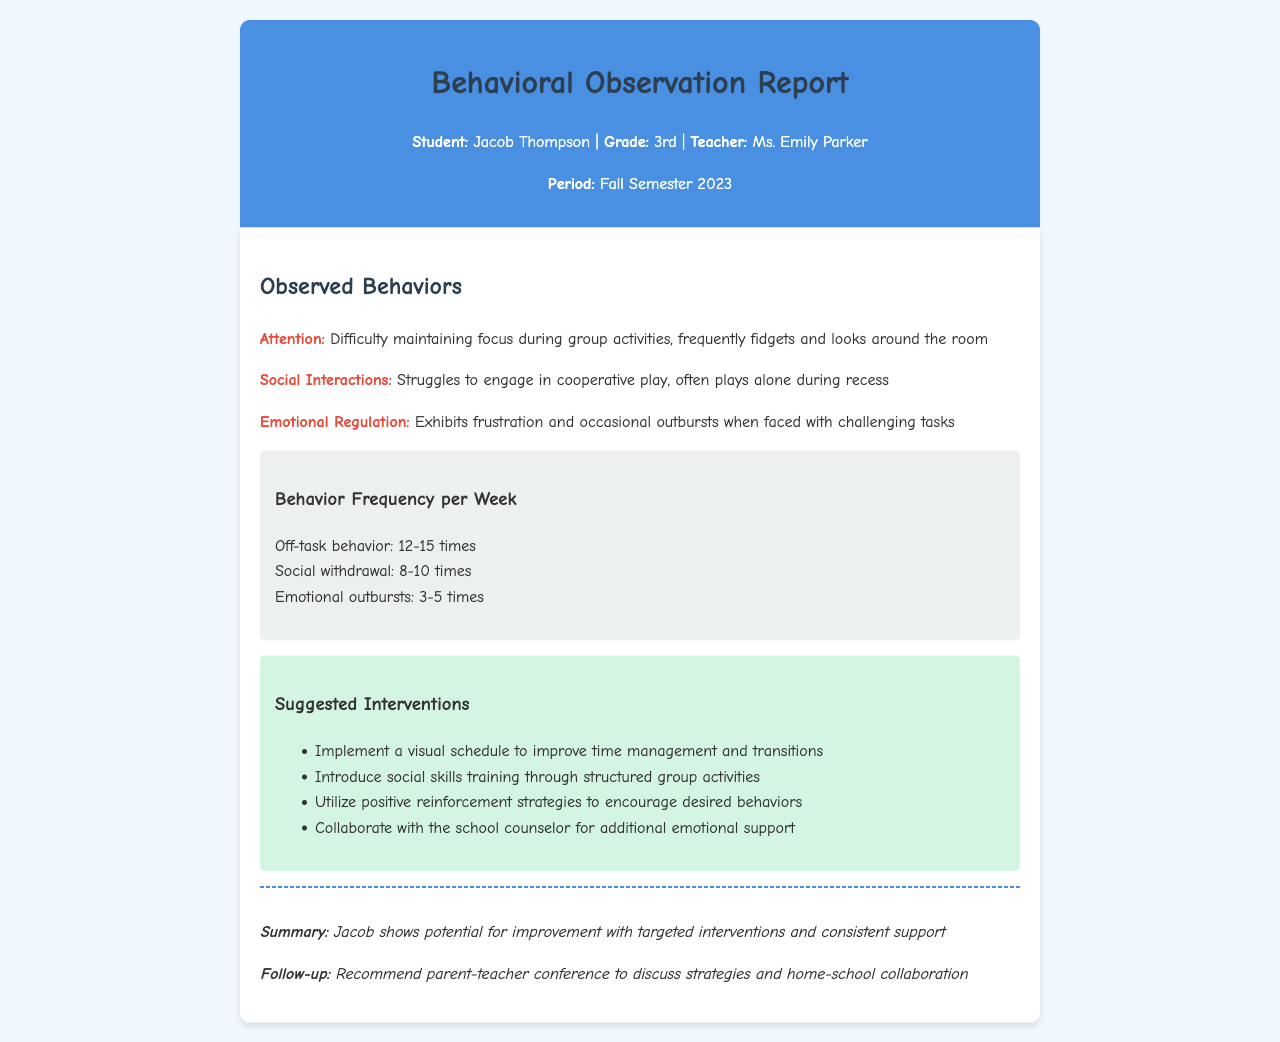What is the student's name? The student's name is clearly stated at the beginning of the document under the student details.
Answer: Jacob Thompson What grade is Jacob in? The grade is mentioned in the student details section of the document.
Answer: 3rd Which teacher is associated with this report? The teacher's name is listed in the student details section.
Answer: Ms. Emily Parker What was the observed frequency of emotional outbursts per week? The frequency of emotional outbursts is provided in the behavior frequency section of the document.
Answer: 3-5 times What suggested intervention involves the school counselor? The suggested interventions section mentions collaboration with the school counselor for additional support.
Answer: Collaborate with the school counselor How often does Jacob display off-task behavior? The document specifies the frequency of off-task behavior in the frequency chart.
Answer: 12-15 times What is a recommended follow-up action mentioned in the conclusion? The follow-up action is listed in the conclusion section of the document.
Answer: Recommend parent-teacher conference What behavioral pattern shows difficulty during group activities? This pattern is outlined in the observed behaviors section, specifically referring to attention issues.
Answer: Attention What is the background color of the fax content section? The background color of the content is described in the style of the document's HTML.
Answer: White 